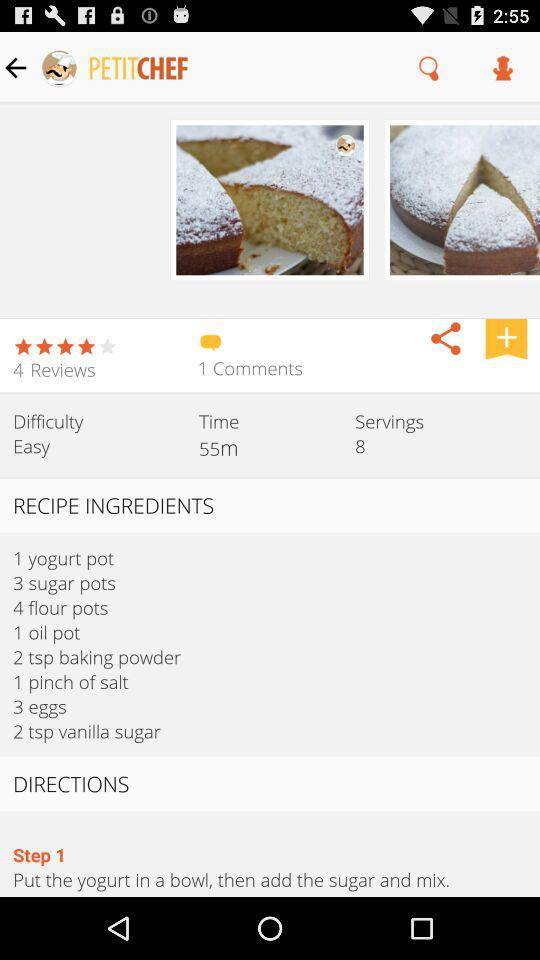What is the duration? The duration is 55 minutes. 